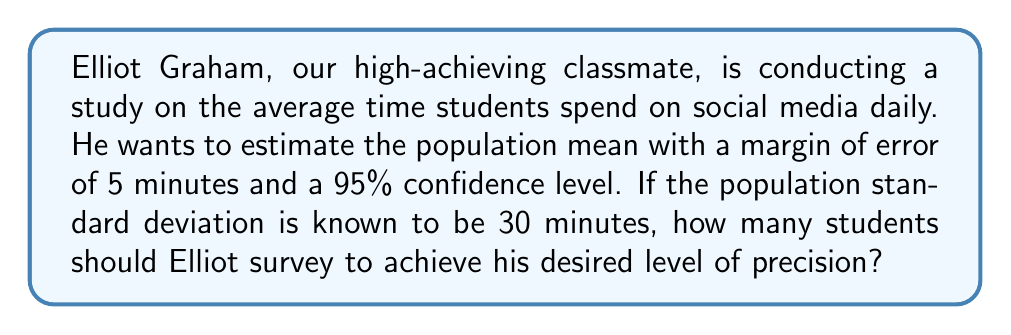Teach me how to tackle this problem. Let's approach this step-by-step:

1) The formula for sample size determination when estimating a population mean is:

   $$n = \left(\frac{z_{\alpha/2} \cdot \sigma}{E}\right)^2$$

   Where:
   $n$ = sample size
   $z_{\alpha/2}$ = critical value of the normal distribution at $\alpha/2$
   $\sigma$ = population standard deviation
   $E$ = margin of error

2) We know:
   - Confidence level = 95%, so $\alpha = 1 - 0.95 = 0.05$
   - $z_{\alpha/2} = z_{0.025} = 1.96$ (from the standard normal table)
   - $\sigma = 30$ minutes
   - $E = 5$ minutes

3) Let's substitute these values into our formula:

   $$n = \left(\frac{1.96 \cdot 30}{5}\right)^2$$

4) Simplify:
   $$n = (11.76)^2 = 138.2976$$

5) Since we can't survey a fractional number of students, we round up to the nearest whole number:

   $n = 139$

Therefore, Elliot needs to survey at least 139 students to estimate the population mean with the desired precision.
Answer: 139 students 